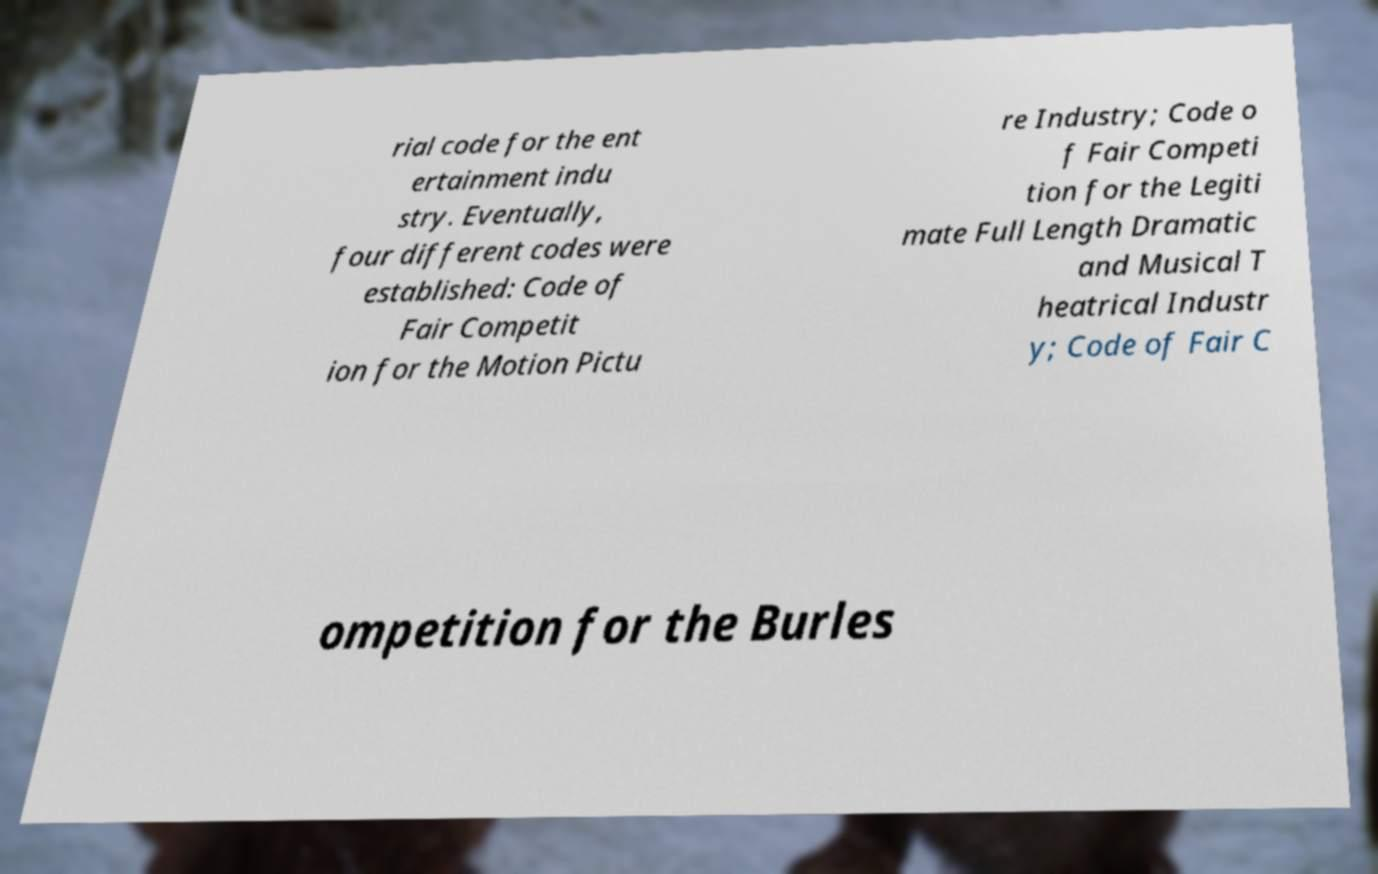I need the written content from this picture converted into text. Can you do that? rial code for the ent ertainment indu stry. Eventually, four different codes were established: Code of Fair Competit ion for the Motion Pictu re Industry; Code o f Fair Competi tion for the Legiti mate Full Length Dramatic and Musical T heatrical Industr y; Code of Fair C ompetition for the Burles 